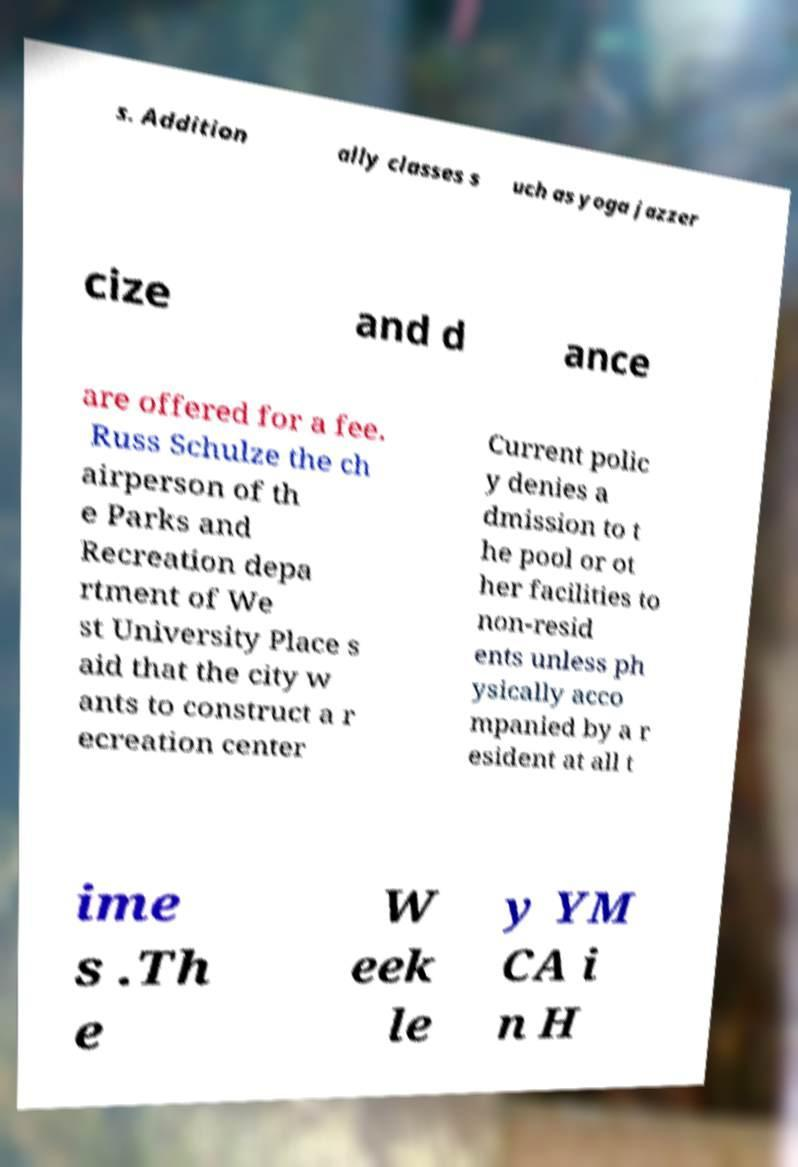I need the written content from this picture converted into text. Can you do that? s. Addition ally classes s uch as yoga jazzer cize and d ance are offered for a fee. Russ Schulze the ch airperson of th e Parks and Recreation depa rtment of We st University Place s aid that the city w ants to construct a r ecreation center Current polic y denies a dmission to t he pool or ot her facilities to non-resid ents unless ph ysically acco mpanied by a r esident at all t ime s .Th e W eek le y YM CA i n H 